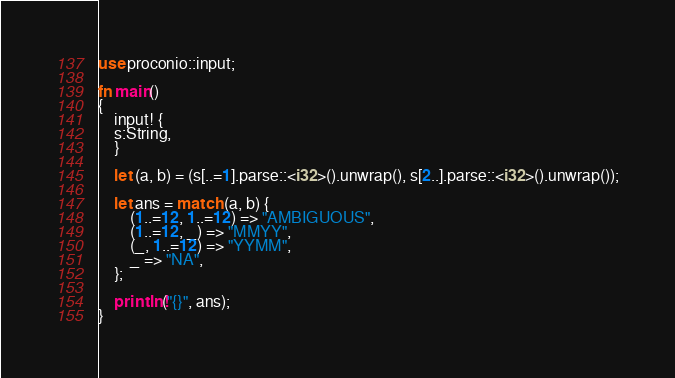<code> <loc_0><loc_0><loc_500><loc_500><_Rust_>use proconio::input;

fn main()
{
    input! {
    s:String,
    }

    let (a, b) = (s[..=1].parse::<i32>().unwrap(), s[2..].parse::<i32>().unwrap());

    let ans = match (a, b) {
        (1..=12, 1..=12) => "AMBIGUOUS",
        (1..=12, _) => "MMYY",
        (_, 1..=12) => "YYMM",
        _ => "NA",
    };

    println!("{}", ans);
}</code> 